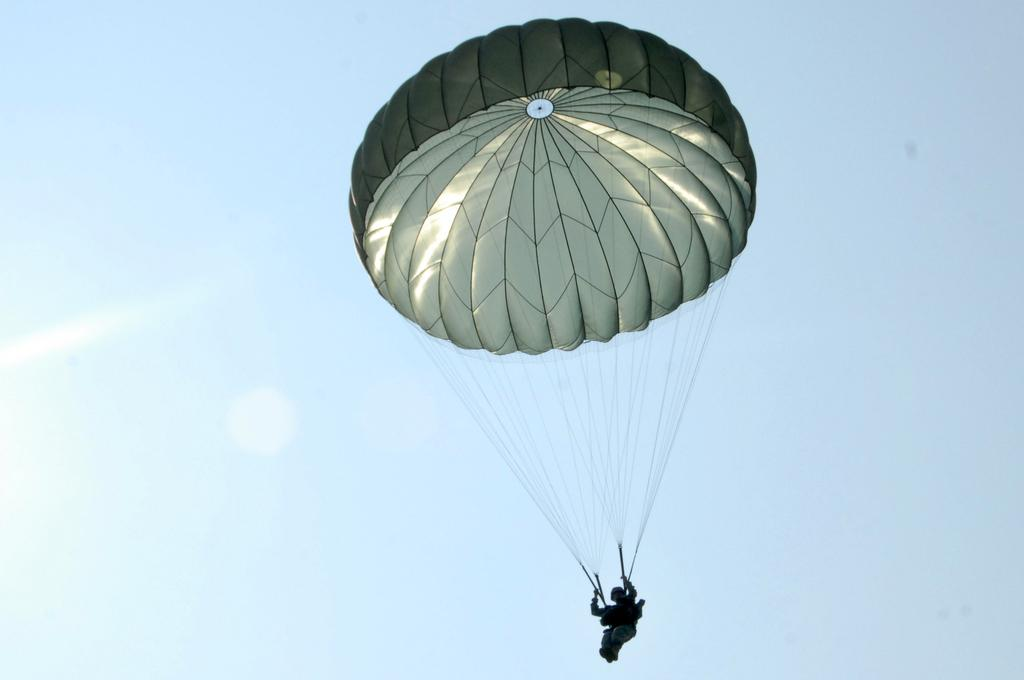What is the main object in the image? There is a parachute in the image. Is there anyone in the image? Yes, there is a person in the image. What can be seen in the background of the image? The sky is visible in the image. What type of mint is being used to flavor the eggs in the image? There are no eggs or mint present in the image; it features a parachute and a person. 